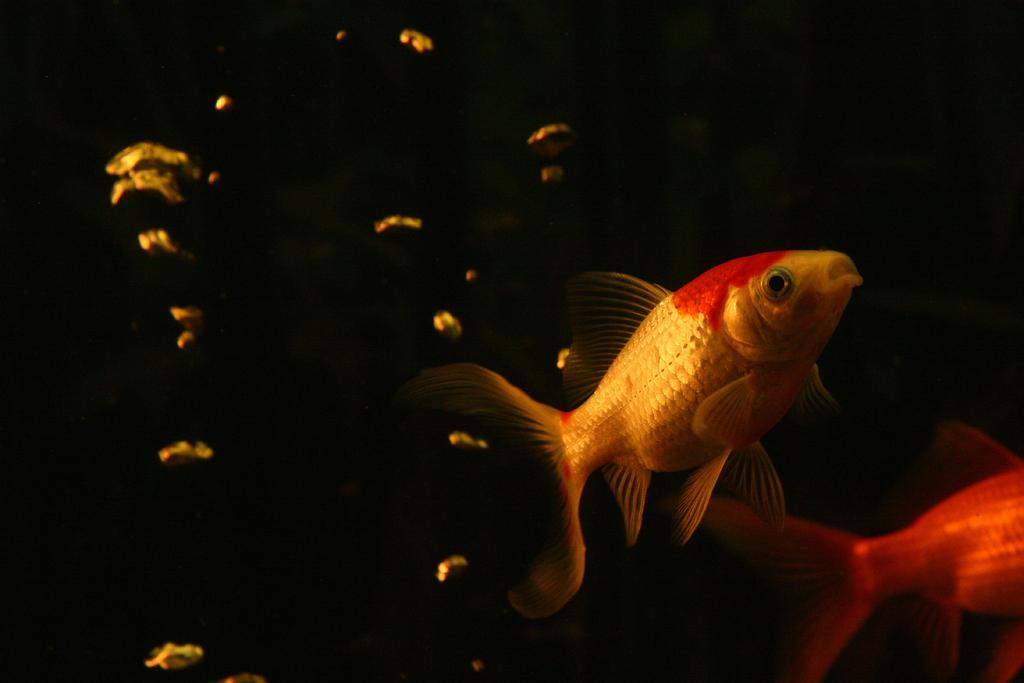What type of animals can be seen in the image? There are fish in the image. What is the color of the background in the image? The background of the image is dark. Can you tell me how many times your grandmother has visited the sky in the image? There is no mention of a grandmother or the sky in the image, so this question cannot be answered. 